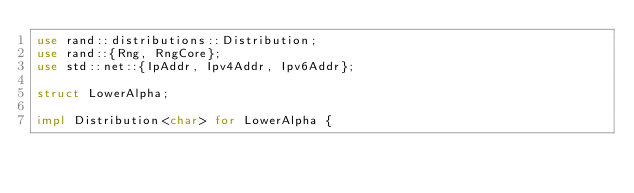<code> <loc_0><loc_0><loc_500><loc_500><_Rust_>use rand::distributions::Distribution;
use rand::{Rng, RngCore};
use std::net::{IpAddr, Ipv4Addr, Ipv6Addr};

struct LowerAlpha;

impl Distribution<char> for LowerAlpha {</code> 